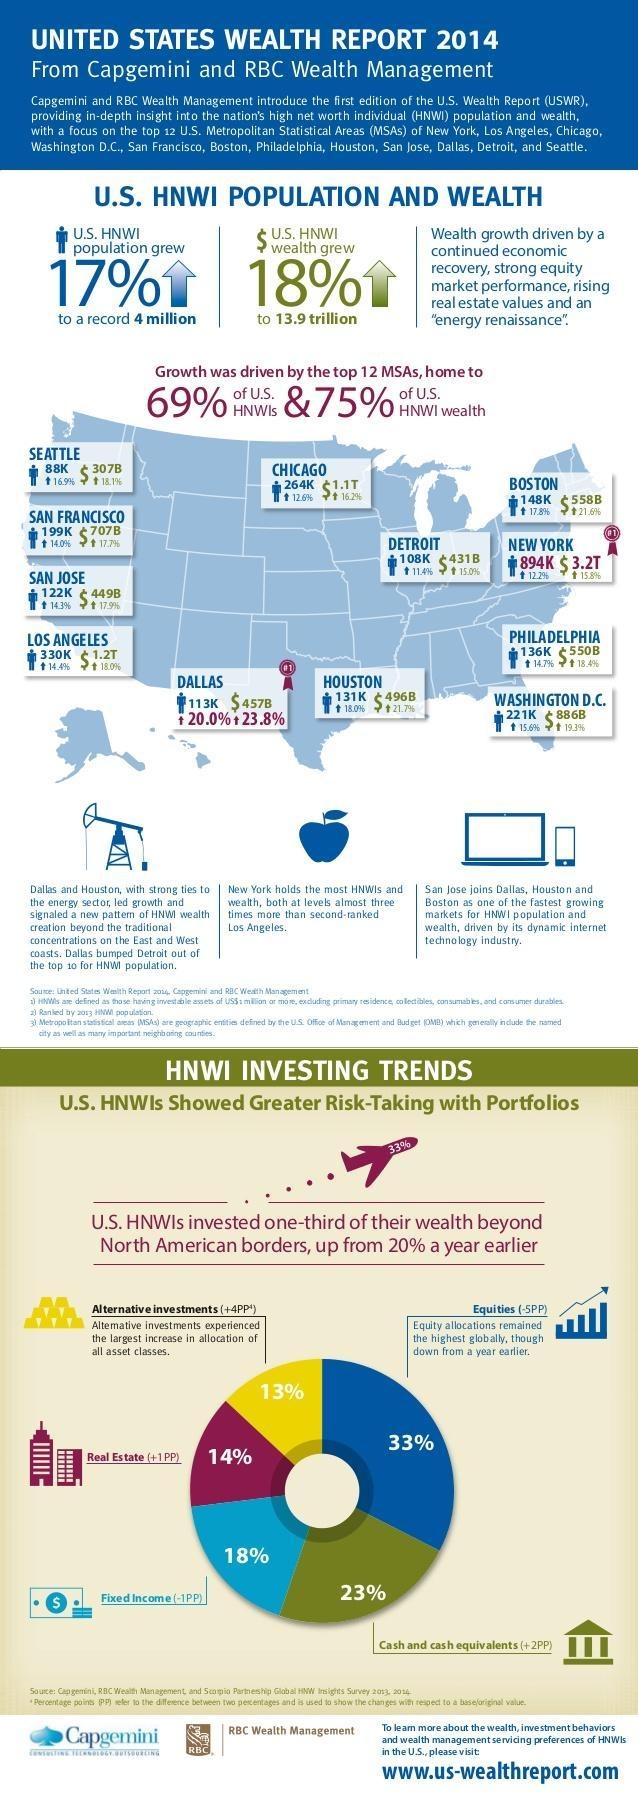What is the U.S. High Net Worth Individual of Wealth grew?
Answer the question with a short phrase. 18% 